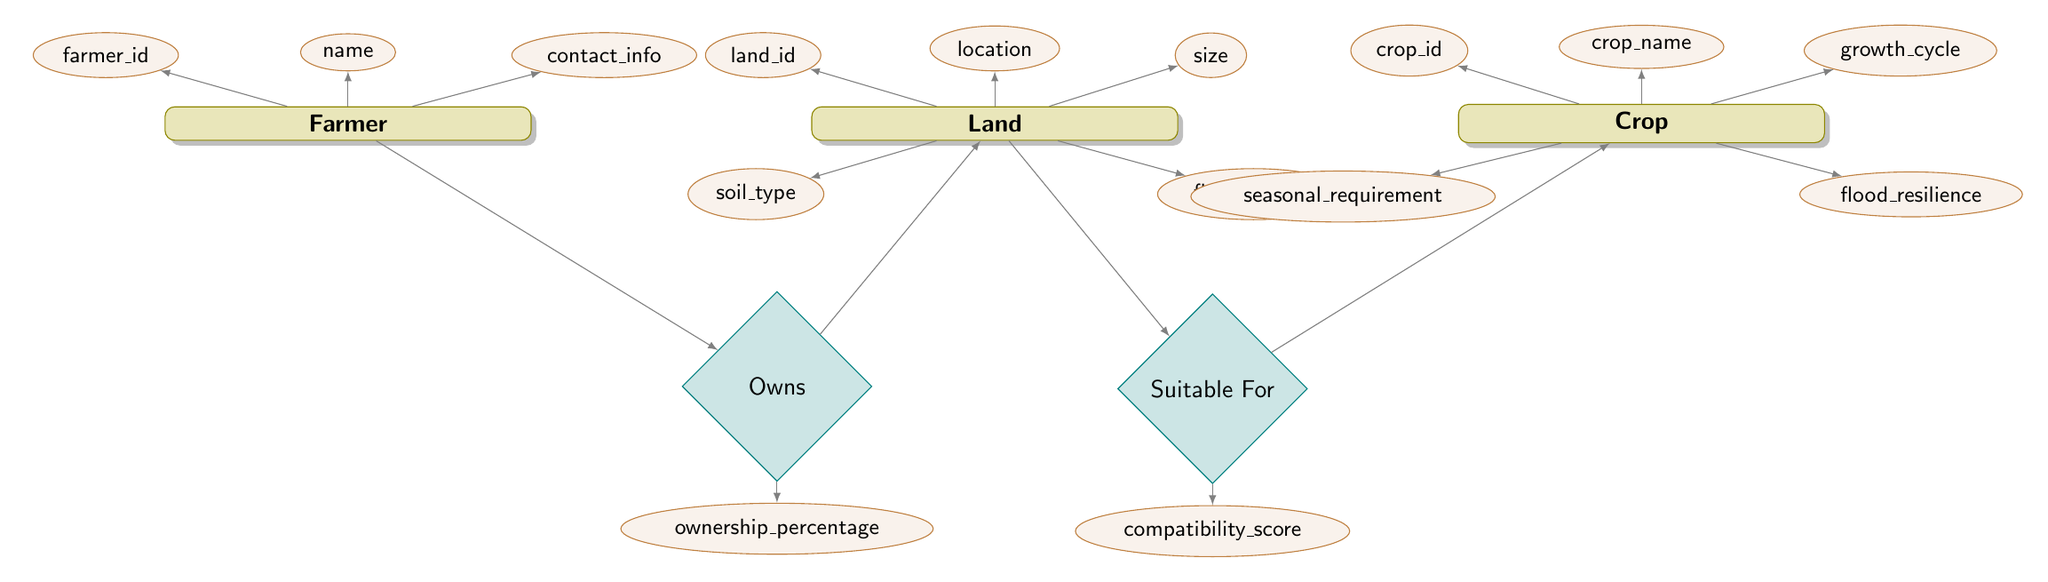What is the primary entity in this diagram? The primary entity represents the main subject of the diagram, which is "Farmer". It is directly connected to the relationship "Owns", indicating that farmers have a key role in land ownership.
Answer: Farmer How many entities are present in this diagram? The entities in the diagram are "Farmer", "Land", and "Crop". Counting these, there are three entities in total.
Answer: 3 What attributes are associated with the "Crop" entity? The attributes associated with the "Crop" entity are "crop_id", "crop_name", "growth_cycle", "seasonal_requirement", and "flood_resilience". There are five attributes linked to this entity.
Answer: 5 What relationship connects "Farmer" to "Land"? The relationship that connects "Farmer" to "Land" is "Owns". This indicates that farmers have ownership over the land.
Answer: Owns What is the compatibility score related to in the diagram? The compatibility score is associated with the relationship "Suitable For", which connects "Land" to "Crop". It evaluates how suitable a specific crop is for a given piece of land.
Answer: Suitable For What is the purpose of the "flood_history" attribute in the "Land" entity? The "flood_history" attribute in the "Land" entity provides information about the past flood occurrences on that land, helping in assessing flood resilience for crop selection.
Answer: Assess flood resilience Which entity has the attribute "ownership_percentage"? The attribute "ownership_percentage" is associated with the relationship "Owns", indicating it is related to the connection between "Farmer" and "Land".
Answer: Owns How many relationships are shown in this diagram? The diagram features two relationships: "Owns" and "Suitable For". Thus, there are two relationships present.
Answer: 2 What does the "flood_resilience" attribute indicate for the "Crop" entity? The "flood_resilience" attribute indicates a crop's ability to withstand flooding conditions, aiding farmers in selecting appropriate crops for areas prone to floods.
Answer: Withstand flooding 